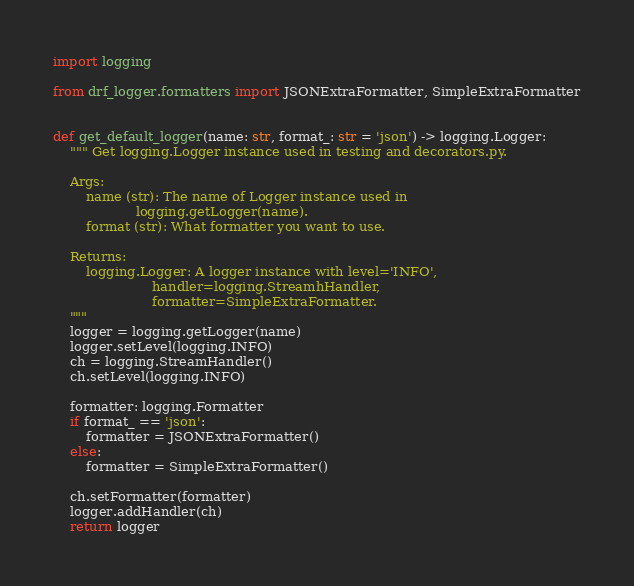<code> <loc_0><loc_0><loc_500><loc_500><_Python_>import logging

from drf_logger.formatters import JSONExtraFormatter, SimpleExtraFormatter


def get_default_logger(name: str, format_: str = 'json') -> logging.Logger:
    """ Get logging.Logger instance used in testing and decorators.py.

    Args:
        name (str): The name of Logger instance used in
                    logging.getLogger(name).
        format (str): What formatter you want to use.

    Returns:
        logging.Logger: A logger instance with level='INFO',
                        handler=logging.StreamhHandler,
                        formatter=SimpleExtraFormatter.
    """
    logger = logging.getLogger(name)
    logger.setLevel(logging.INFO)
    ch = logging.StreamHandler()
    ch.setLevel(logging.INFO)

    formatter: logging.Formatter
    if format_ == 'json':
        formatter = JSONExtraFormatter()
    else:
        formatter = SimpleExtraFormatter()

    ch.setFormatter(formatter)
    logger.addHandler(ch)
    return logger
</code> 